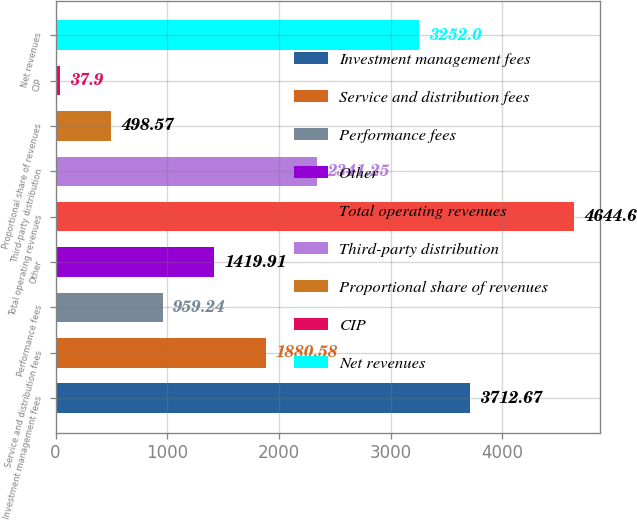Convert chart. <chart><loc_0><loc_0><loc_500><loc_500><bar_chart><fcel>Investment management fees<fcel>Service and distribution fees<fcel>Performance fees<fcel>Other<fcel>Total operating revenues<fcel>Third-party distribution<fcel>Proportional share of revenues<fcel>CIP<fcel>Net revenues<nl><fcel>3712.67<fcel>1880.58<fcel>959.24<fcel>1419.91<fcel>4644.6<fcel>2341.25<fcel>498.57<fcel>37.9<fcel>3252<nl></chart> 